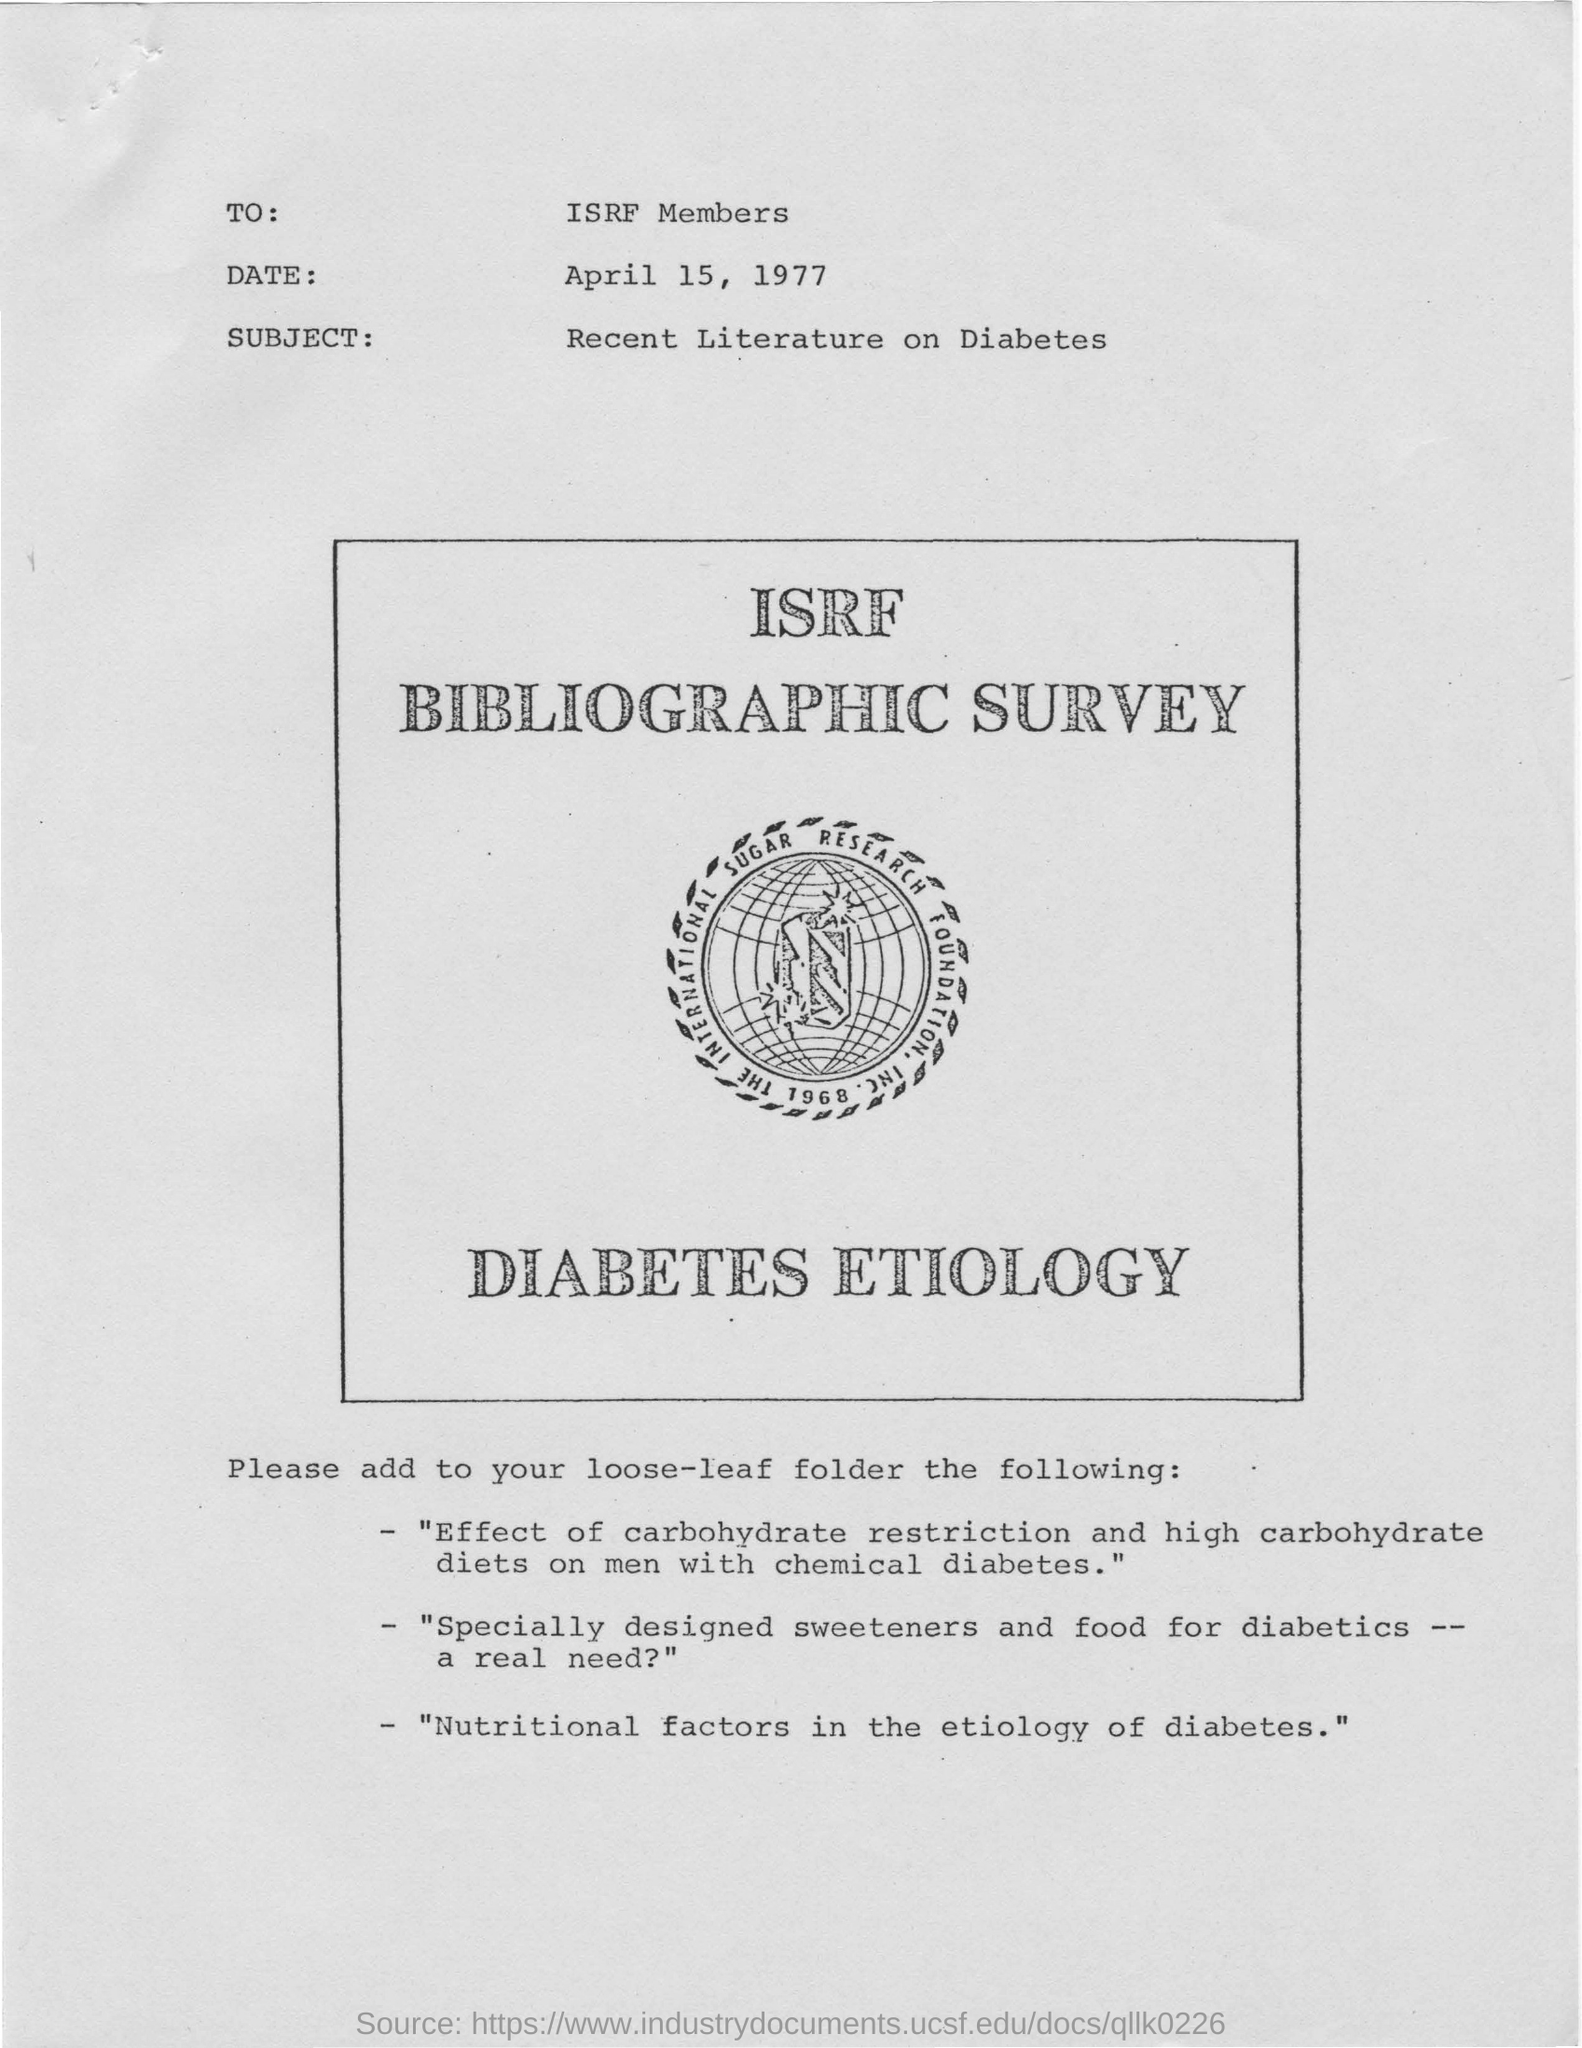Point out several critical features in this image. The date mentioned in the survey is April 15, 1977. The subject of the survey is recent literature on diabetes. The text that is written directly below the logo is "diabetes etiology. 